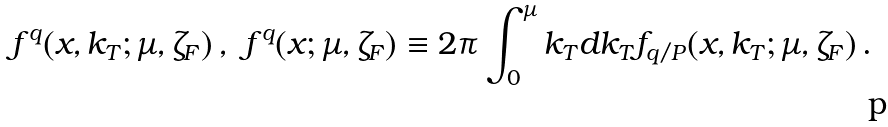<formula> <loc_0><loc_0><loc_500><loc_500>f ^ { q } ( x , k _ { T } ; \mu , \zeta _ { F } ) \, , & & f ^ { q } ( x ; \mu , \zeta _ { F } ) & \equiv 2 \pi \int _ { 0 } ^ { \mu } k _ { T } d k _ { T } f _ { q / P } ( x , k _ { T } ; \mu , \zeta _ { F } ) \, .</formula> 